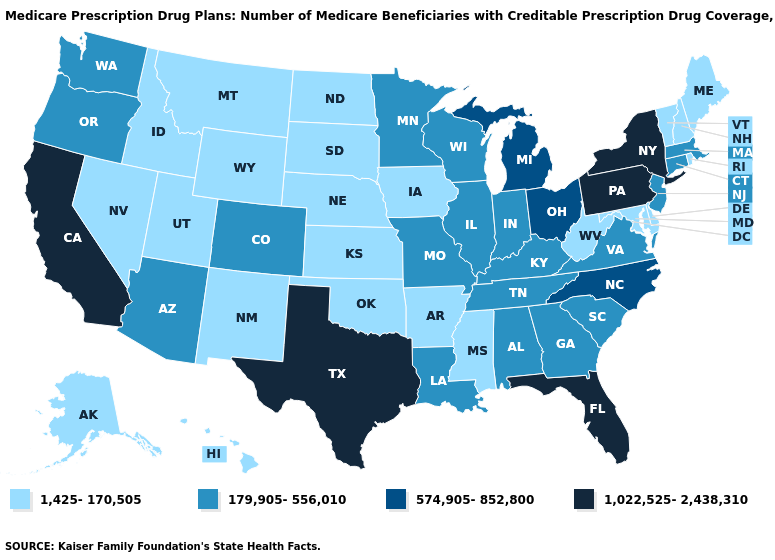Name the states that have a value in the range 1,425-170,505?
Keep it brief. Alaska, Arkansas, Delaware, Hawaii, Idaho, Iowa, Kansas, Maine, Maryland, Mississippi, Montana, Nebraska, Nevada, New Hampshire, New Mexico, North Dakota, Oklahoma, Rhode Island, South Dakota, Utah, Vermont, West Virginia, Wyoming. What is the value of Louisiana?
Short answer required. 179,905-556,010. What is the value of Maryland?
Quick response, please. 1,425-170,505. Name the states that have a value in the range 574,905-852,800?
Be succinct. Michigan, North Carolina, Ohio. Does Mississippi have the same value as Louisiana?
Keep it brief. No. What is the highest value in the West ?
Keep it brief. 1,022,525-2,438,310. What is the highest value in states that border Indiana?
Short answer required. 574,905-852,800. Among the states that border South Dakota , does Minnesota have the highest value?
Quick response, please. Yes. What is the lowest value in the USA?
Quick response, please. 1,425-170,505. Among the states that border Tennessee , does North Carolina have the highest value?
Answer briefly. Yes. Does Oregon have a higher value than Pennsylvania?
Be succinct. No. What is the highest value in the USA?
Concise answer only. 1,022,525-2,438,310. Which states hav the highest value in the Northeast?
Concise answer only. New York, Pennsylvania. Does the map have missing data?
Give a very brief answer. No. Among the states that border California , does Arizona have the lowest value?
Be succinct. No. 